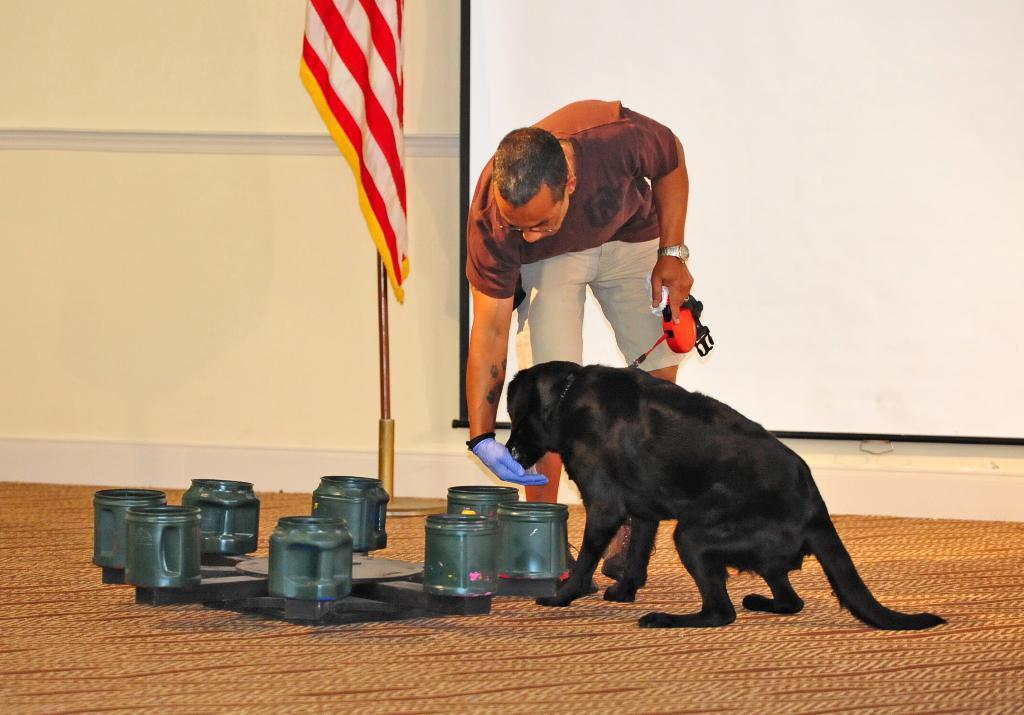Can you describe this image briefly? In this image in the center there is one person he is holding something, and he is feeding the dog. And there is one dog, and on the left side there are some objects. At the bottom there is floor, and in the background there is a screen, pole, flag and wall. 